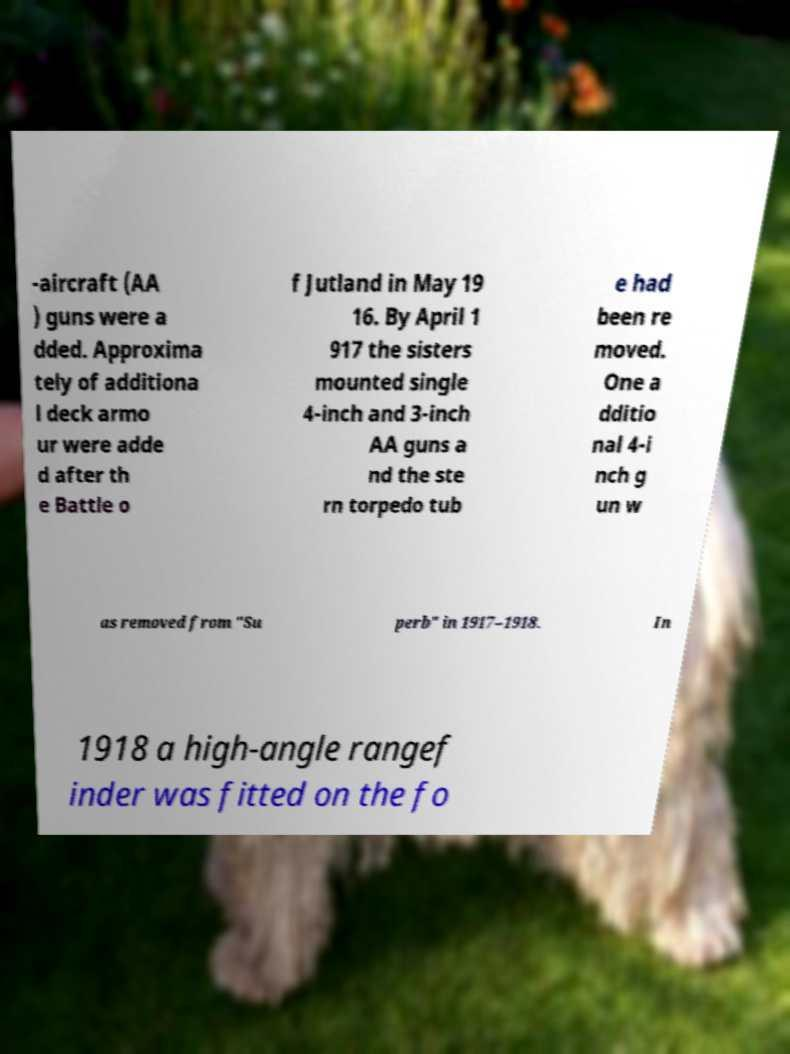For documentation purposes, I need the text within this image transcribed. Could you provide that? -aircraft (AA ) guns were a dded. Approxima tely of additiona l deck armo ur were adde d after th e Battle o f Jutland in May 19 16. By April 1 917 the sisters mounted single 4-inch and 3-inch AA guns a nd the ste rn torpedo tub e had been re moved. One a dditio nal 4-i nch g un w as removed from "Su perb" in 1917–1918. In 1918 a high-angle rangef inder was fitted on the fo 